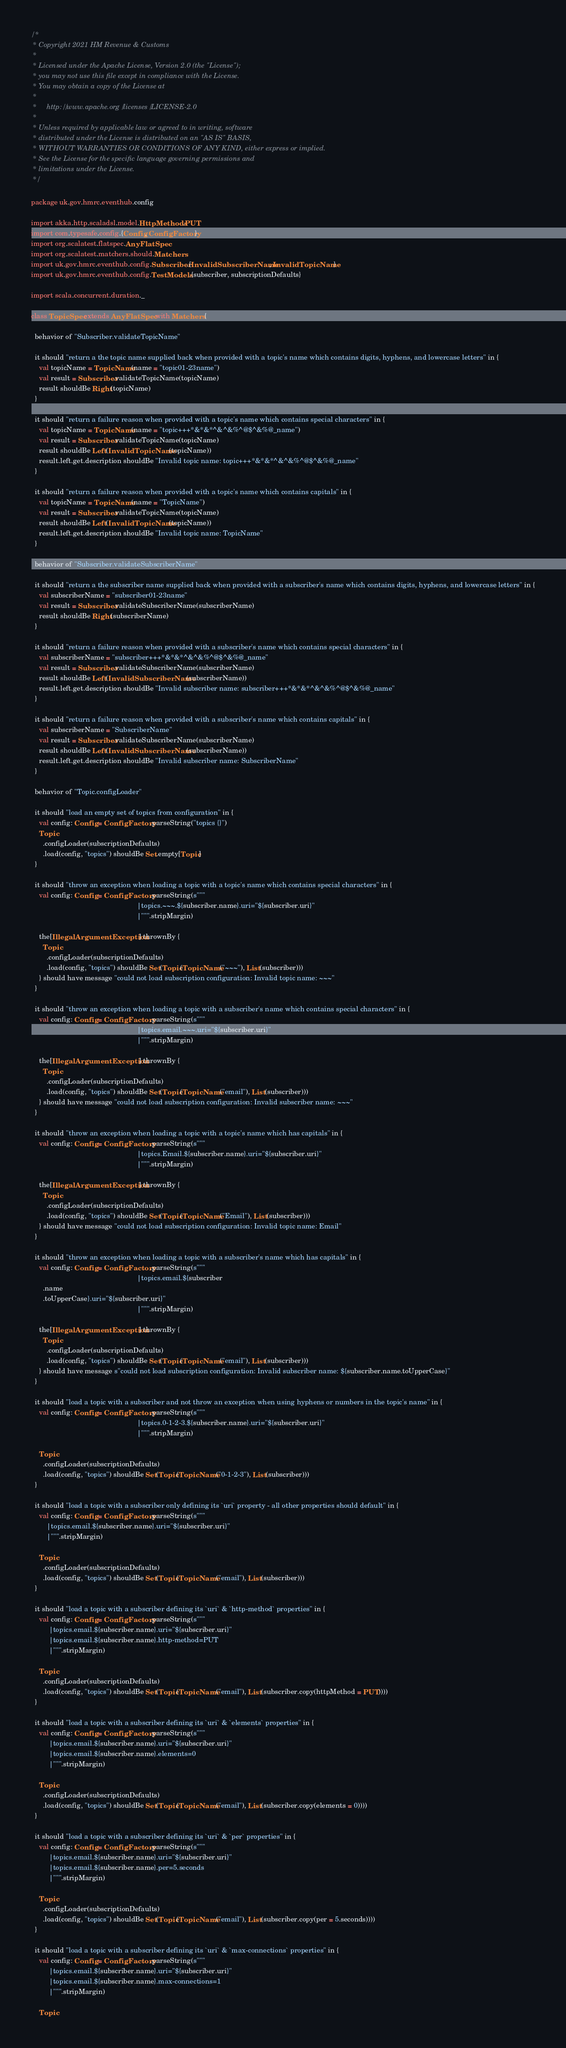Convert code to text. <code><loc_0><loc_0><loc_500><loc_500><_Scala_>/*
 * Copyright 2021 HM Revenue & Customs
 *
 * Licensed under the Apache License, Version 2.0 (the "License");
 * you may not use this file except in compliance with the License.
 * You may obtain a copy of the License at
 *
 *     http://www.apache.org/licenses/LICENSE-2.0
 *
 * Unless required by applicable law or agreed to in writing, software
 * distributed under the License is distributed on an "AS IS" BASIS,
 * WITHOUT WARRANTIES OR CONDITIONS OF ANY KIND, either express or implied.
 * See the License for the specific language governing permissions and
 * limitations under the License.
 */

package uk.gov.hmrc.eventhub.config

import akka.http.scaladsl.model.HttpMethods.PUT
import com.typesafe.config.{Config, ConfigFactory}
import org.scalatest.flatspec.AnyFlatSpec
import org.scalatest.matchers.should.Matchers
import uk.gov.hmrc.eventhub.config.Subscriber.{InvalidSubscriberName, InvalidTopicName}
import uk.gov.hmrc.eventhub.config.TestModels.{subscriber, subscriptionDefaults}

import scala.concurrent.duration._

class TopicSpec extends AnyFlatSpec with Matchers {

  behavior of "Subscriber.validateTopicName"

  it should "return a the topic name supplied back when provided with a topic's name which contains digits, hyphens, and lowercase letters" in {
    val topicName = TopicName(name = "topic01-23name")
    val result = Subscriber.validateTopicName(topicName)
    result shouldBe Right(topicName)
  }

  it should "return a failure reason when provided with a topic's name which contains special characters" in {
    val topicName = TopicName(name = "topic+++*&*&*^&^&%^@$^&%@_name")
    val result = Subscriber.validateTopicName(topicName)
    result shouldBe Left(InvalidTopicName(topicName))
    result.left.get.description shouldBe "Invalid topic name: topic+++*&*&*^&^&%^@$^&%@_name"
  }

  it should "return a failure reason when provided with a topic's name which contains capitals" in {
    val topicName = TopicName(name = "TopicName")
    val result = Subscriber.validateTopicName(topicName)
    result shouldBe Left(InvalidTopicName(topicName))
    result.left.get.description shouldBe "Invalid topic name: TopicName"
  }

  behavior of "Subscriber.validateSubscriberName"

  it should "return a the subscriber name supplied back when provided with a subscriber's name which contains digits, hyphens, and lowercase letters" in {
    val subscriberName = "subscriber01-23name"
    val result = Subscriber.validateSubscriberName(subscriberName)
    result shouldBe Right(subscriberName)
  }

  it should "return a failure reason when provided with a subscriber's name which contains special characters" in {
    val subscriberName = "subscriber+++*&*&*^&^&%^@$^&%@_name"
    val result = Subscriber.validateSubscriberName(subscriberName)
    result shouldBe Left(InvalidSubscriberName(subscriberName))
    result.left.get.description shouldBe "Invalid subscriber name: subscriber+++*&*&*^&^&%^@$^&%@_name"
  }

  it should "return a failure reason when provided with a subscriber's name which contains capitals" in {
    val subscriberName = "SubscriberName"
    val result = Subscriber.validateSubscriberName(subscriberName)
    result shouldBe Left(InvalidSubscriberName(subscriberName))
    result.left.get.description shouldBe "Invalid subscriber name: SubscriberName"
  }

  behavior of "Topic.configLoader"

  it should "load an empty set of topics from configuration" in {
    val config: Config = ConfigFactory.parseString("topics {}")
    Topic
      .configLoader(subscriptionDefaults)
      .load(config, "topics") shouldBe Set.empty[Topic]
  }

  it should "throw an exception when loading a topic with a topic's name which contains special characters" in {
    val config: Config = ConfigFactory.parseString(s"""
                                                      |topics.~~~.${subscriber.name}.uri="${subscriber.uri}"
                                                      |""".stripMargin)

    the[IllegalArgumentException] thrownBy {
      Topic
        .configLoader(subscriptionDefaults)
        .load(config, "topics") shouldBe Set(Topic(TopicName("~~~"), List(subscriber)))
    } should have message "could not load subscription configuration: Invalid topic name: ~~~"
  }

  it should "throw an exception when loading a topic with a subscriber's name which contains special characters" in {
    val config: Config = ConfigFactory.parseString(s"""
                                                      |topics.email.~~~.uri="${subscriber.uri}"
                                                      |""".stripMargin)

    the[IllegalArgumentException] thrownBy {
      Topic
        .configLoader(subscriptionDefaults)
        .load(config, "topics") shouldBe Set(Topic(TopicName("email"), List(subscriber)))
    } should have message "could not load subscription configuration: Invalid subscriber name: ~~~"
  }

  it should "throw an exception when loading a topic with a topic's name which has capitals" in {
    val config: Config = ConfigFactory.parseString(s"""
                                                      |topics.Email.${subscriber.name}.uri="${subscriber.uri}"
                                                      |""".stripMargin)

    the[IllegalArgumentException] thrownBy {
      Topic
        .configLoader(subscriptionDefaults)
        .load(config, "topics") shouldBe Set(Topic(TopicName("Email"), List(subscriber)))
    } should have message "could not load subscription configuration: Invalid topic name: Email"
  }

  it should "throw an exception when loading a topic with a subscriber's name which has capitals" in {
    val config: Config = ConfigFactory.parseString(s"""
                                                      |topics.email.${subscriber
      .name
      .toUpperCase}.uri="${subscriber.uri}"
                                                      |""".stripMargin)

    the[IllegalArgumentException] thrownBy {
      Topic
        .configLoader(subscriptionDefaults)
        .load(config, "topics") shouldBe Set(Topic(TopicName("email"), List(subscriber)))
    } should have message s"could not load subscription configuration: Invalid subscriber name: ${subscriber.name.toUpperCase}"
  }

  it should "load a topic with a subscriber and not throw an exception when using hyphens or numbers in the topic's name" in {
    val config: Config = ConfigFactory.parseString(s"""
                                                      |topics.0-1-2-3.${subscriber.name}.uri="${subscriber.uri}"
                                                      |""".stripMargin)

    Topic
      .configLoader(subscriptionDefaults)
      .load(config, "topics") shouldBe Set(Topic(TopicName("0-1-2-3"), List(subscriber)))
  }

  it should "load a topic with a subscriber only defining its `uri` property - all other properties should default" in {
    val config: Config = ConfigFactory.parseString(s"""
        |topics.email.${subscriber.name}.uri="${subscriber.uri}"
        |""".stripMargin)

    Topic
      .configLoader(subscriptionDefaults)
      .load(config, "topics") shouldBe Set(Topic(TopicName("email"), List(subscriber)))
  }

  it should "load a topic with a subscriber defining its `uri` & `http-method` properties" in {
    val config: Config = ConfigFactory.parseString(s"""
         |topics.email.${subscriber.name}.uri="${subscriber.uri}"
         |topics.email.${subscriber.name}.http-method=PUT
         |""".stripMargin)

    Topic
      .configLoader(subscriptionDefaults)
      .load(config, "topics") shouldBe Set(Topic(TopicName("email"), List(subscriber.copy(httpMethod = PUT))))
  }

  it should "load a topic with a subscriber defining its `uri` & `elements` properties" in {
    val config: Config = ConfigFactory.parseString(s"""
         |topics.email.${subscriber.name}.uri="${subscriber.uri}"
         |topics.email.${subscriber.name}.elements=0
         |""".stripMargin)

    Topic
      .configLoader(subscriptionDefaults)
      .load(config, "topics") shouldBe Set(Topic(TopicName("email"), List(subscriber.copy(elements = 0))))
  }

  it should "load a topic with a subscriber defining its `uri` & `per` properties" in {
    val config: Config = ConfigFactory.parseString(s"""
         |topics.email.${subscriber.name}.uri="${subscriber.uri}"
         |topics.email.${subscriber.name}.per=5.seconds
         |""".stripMargin)

    Topic
      .configLoader(subscriptionDefaults)
      .load(config, "topics") shouldBe Set(Topic(TopicName("email"), List(subscriber.copy(per = 5.seconds))))
  }

  it should "load a topic with a subscriber defining its `uri` & `max-connections` properties" in {
    val config: Config = ConfigFactory.parseString(s"""
         |topics.email.${subscriber.name}.uri="${subscriber.uri}"
         |topics.email.${subscriber.name}.max-connections=1
         |""".stripMargin)

    Topic</code> 